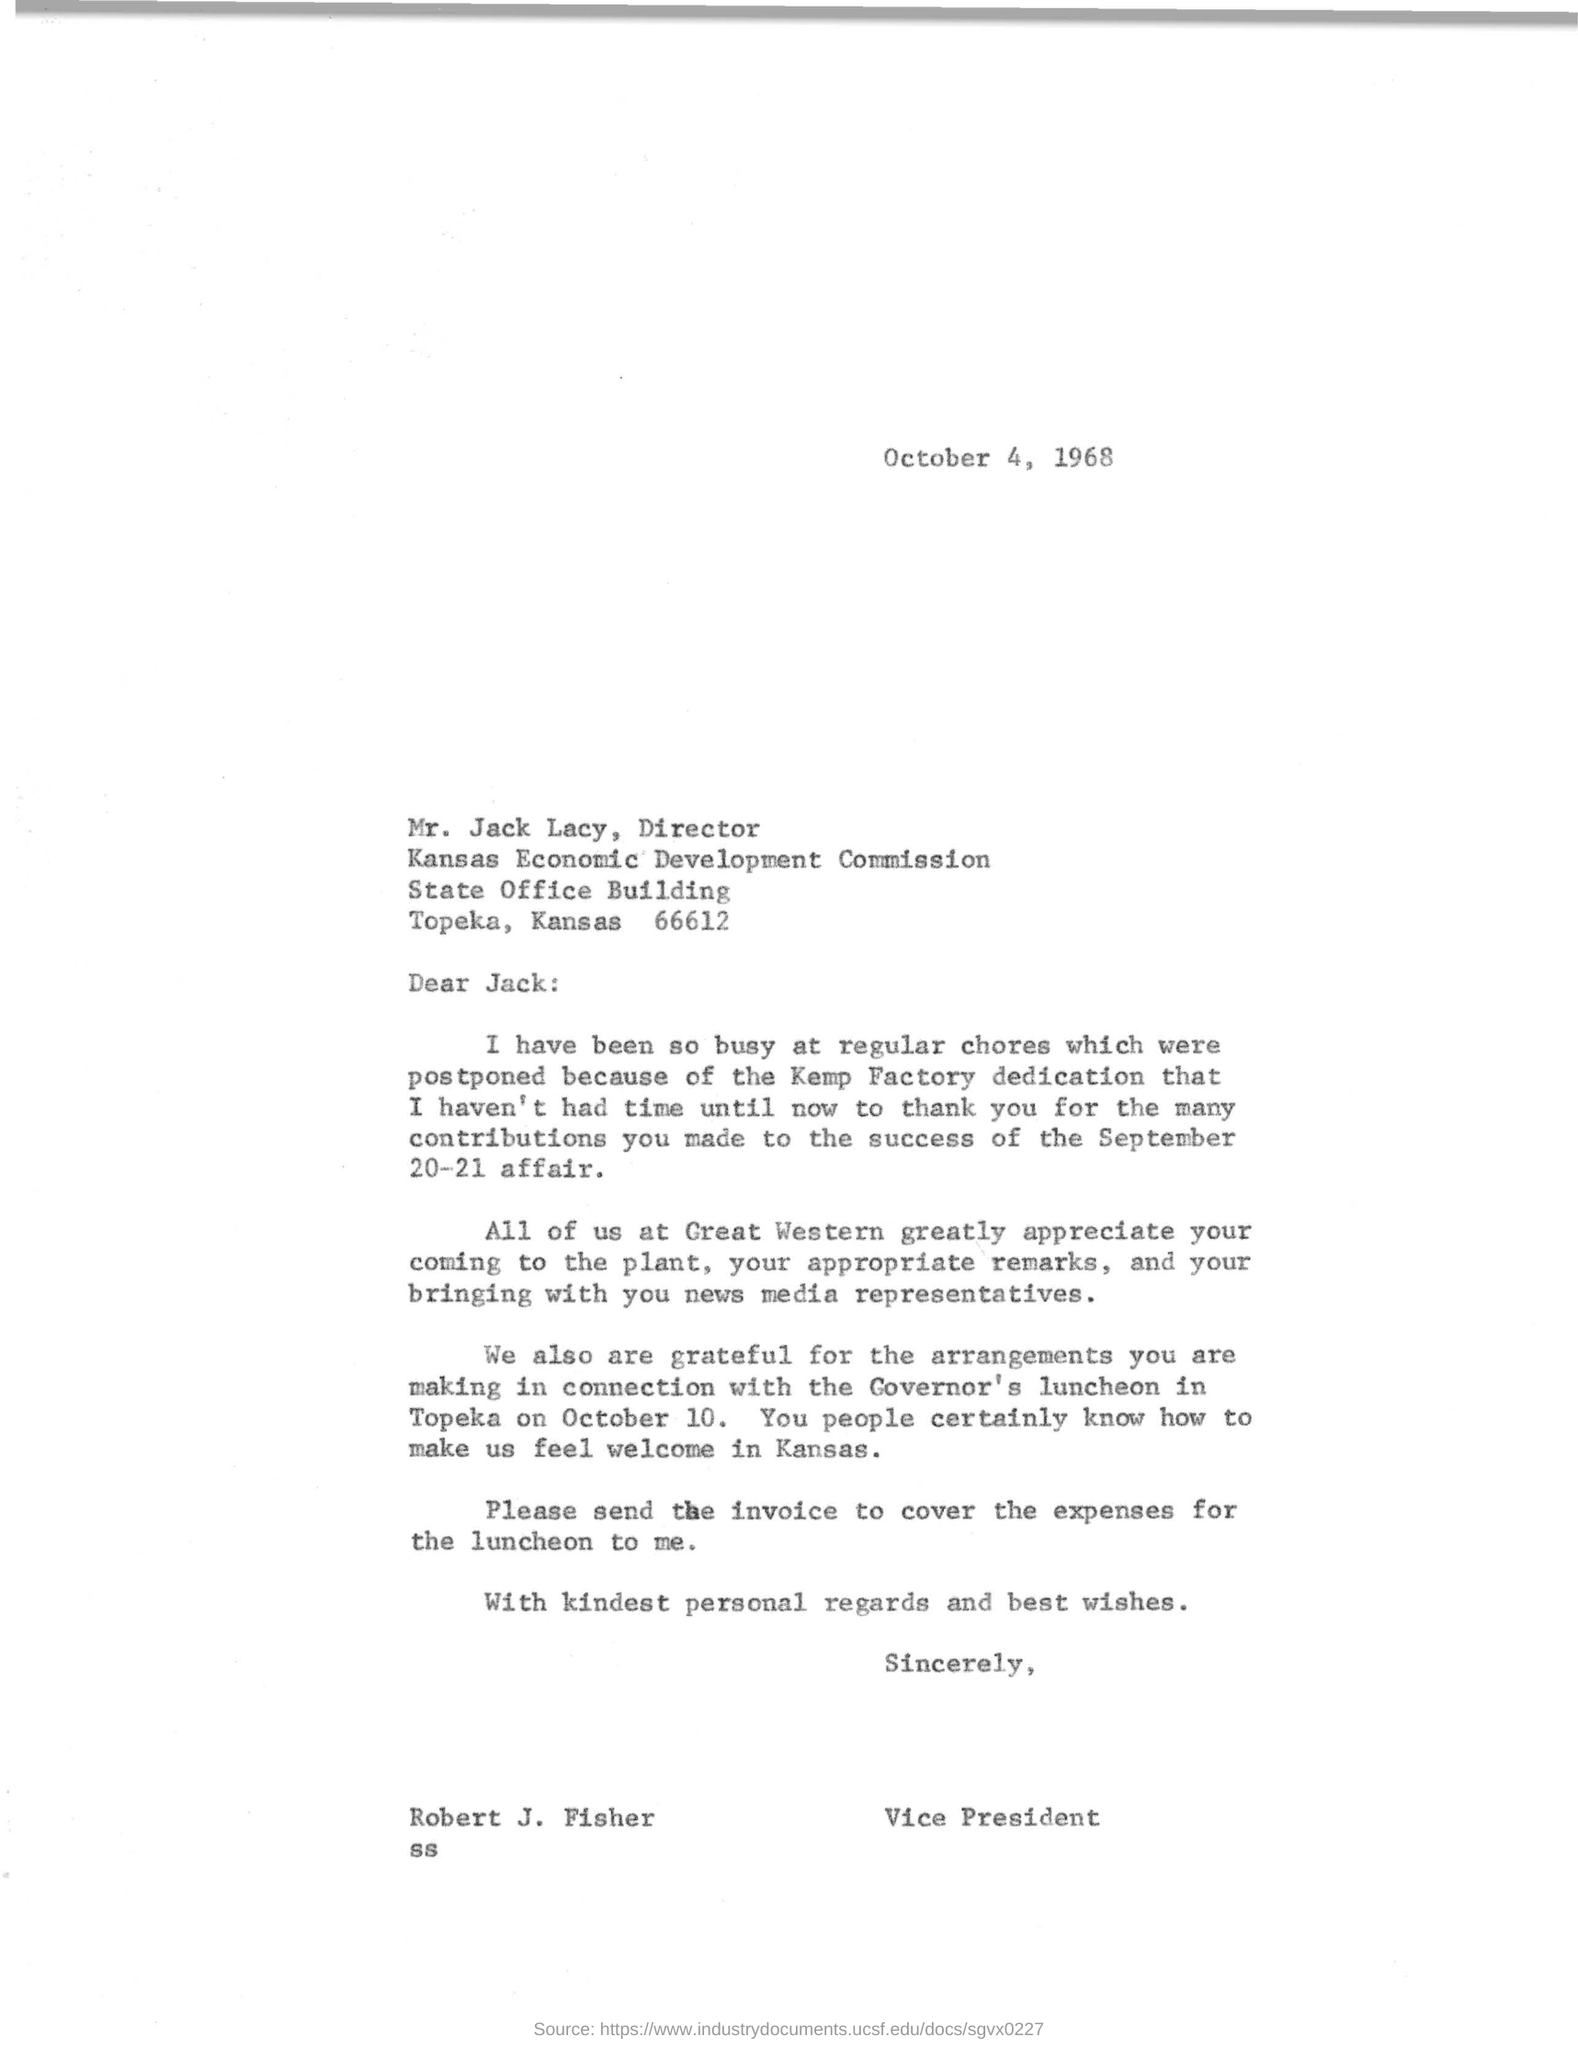Outline some significant characteristics in this image. I, Mr. Jack, brought with me to Great Western several news media representatives for which Mr. Robert is expressing gratitude. On October 4, 1968, Mr. Robert wrote to Mr. Jack. The appointment of Mr. Jack as the Director has been made. Robert J. Fisher is thanking Mr. Jack for the September 20-21 affair. Robert Fisher is currently employed by Great Western. 